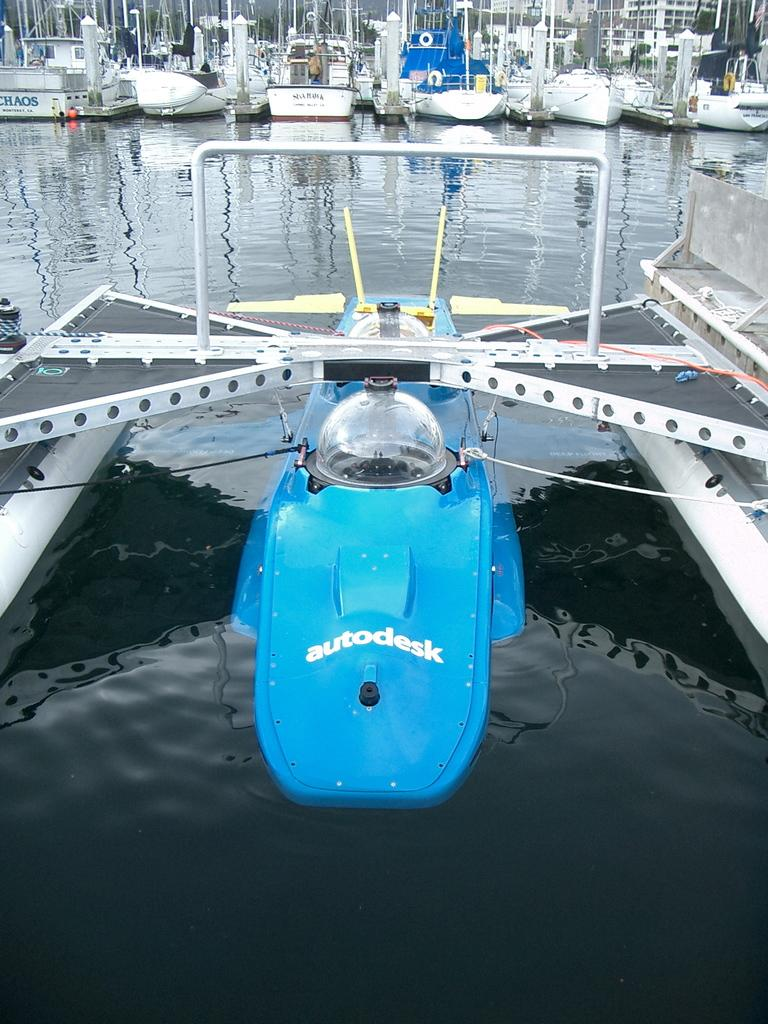<image>
Summarize the visual content of the image. The blue autodesk water jet in sitting in the water. 